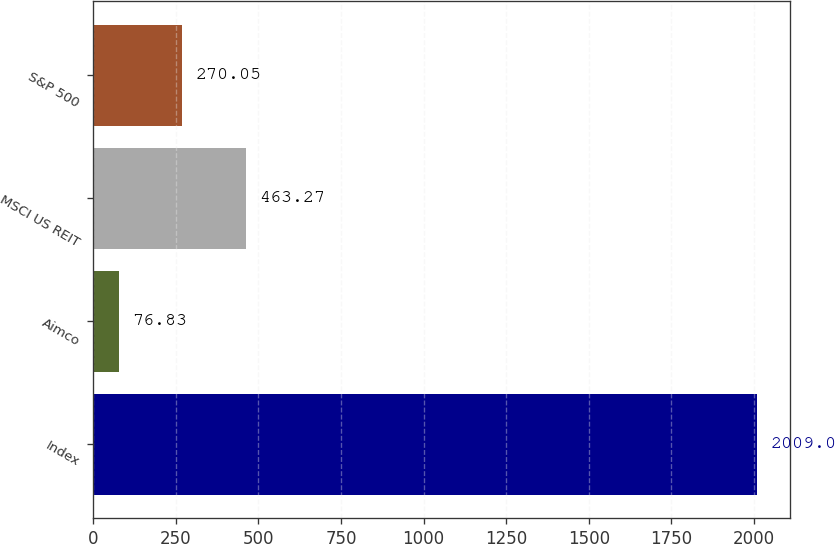Convert chart. <chart><loc_0><loc_0><loc_500><loc_500><bar_chart><fcel>Index<fcel>Aimco<fcel>MSCI US REIT<fcel>S&P 500<nl><fcel>2009<fcel>76.83<fcel>463.27<fcel>270.05<nl></chart> 